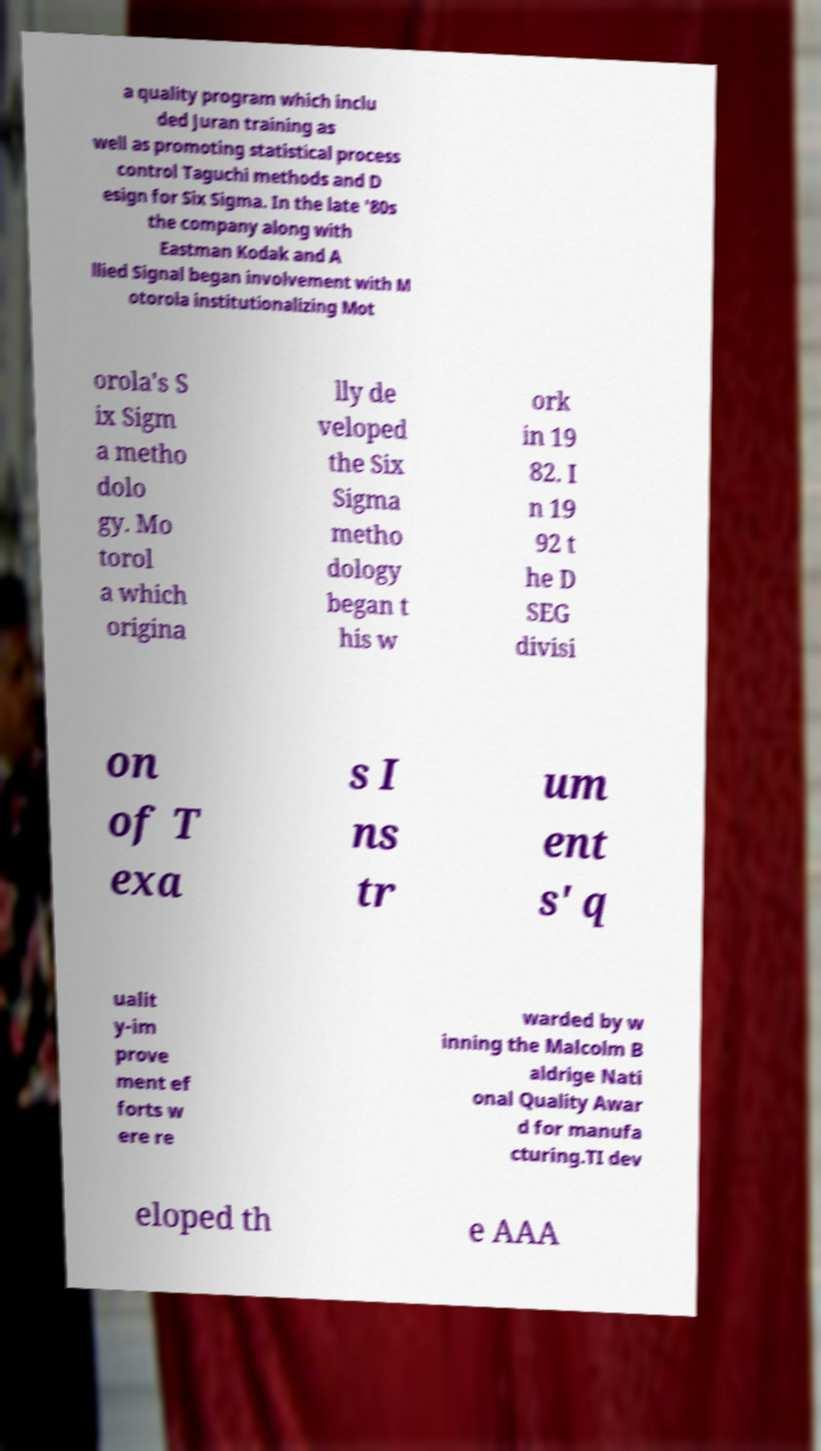Please identify and transcribe the text found in this image. a quality program which inclu ded Juran training as well as promoting statistical process control Taguchi methods and D esign for Six Sigma. In the late '80s the company along with Eastman Kodak and A llied Signal began involvement with M otorola institutionalizing Mot orola's S ix Sigm a metho dolo gy. Mo torol a which origina lly de veloped the Six Sigma metho dology began t his w ork in 19 82. I n 19 92 t he D SEG divisi on of T exa s I ns tr um ent s' q ualit y-im prove ment ef forts w ere re warded by w inning the Malcolm B aldrige Nati onal Quality Awar d for manufa cturing.TI dev eloped th e AAA 